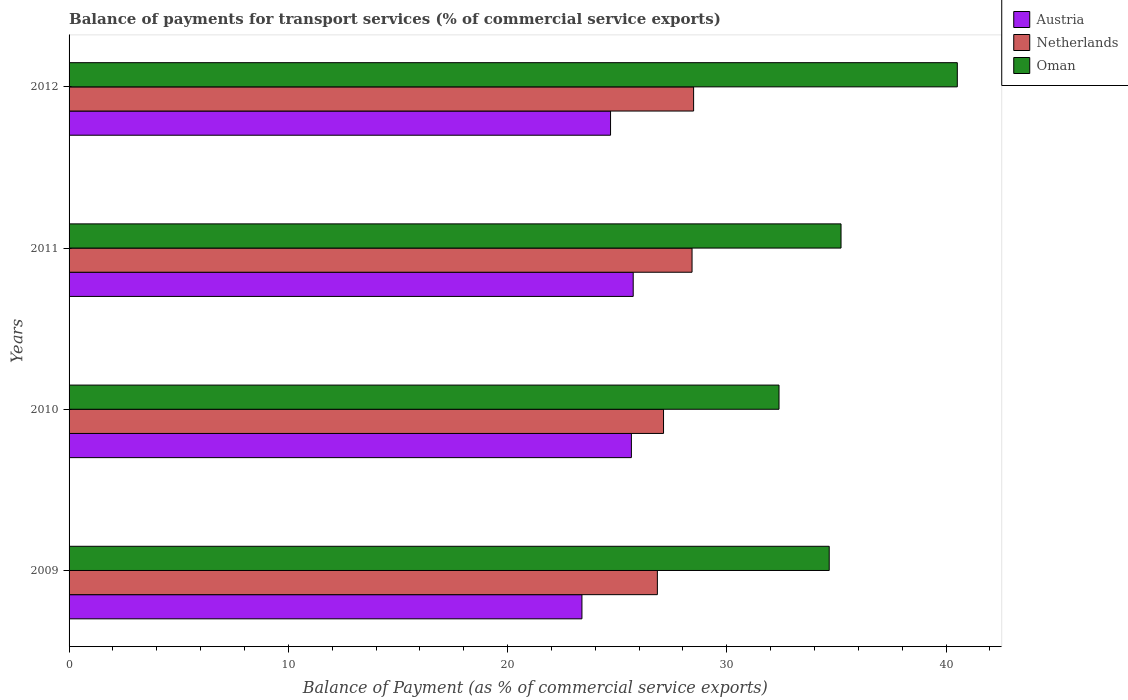How many groups of bars are there?
Offer a very short reply. 4. Are the number of bars on each tick of the Y-axis equal?
Offer a terse response. Yes. How many bars are there on the 4th tick from the top?
Provide a short and direct response. 3. What is the balance of payments for transport services in Oman in 2012?
Your answer should be compact. 40.51. Across all years, what is the maximum balance of payments for transport services in Oman?
Your answer should be very brief. 40.51. Across all years, what is the minimum balance of payments for transport services in Netherlands?
Make the answer very short. 26.83. In which year was the balance of payments for transport services in Oman maximum?
Ensure brevity in your answer.  2012. What is the total balance of payments for transport services in Austria in the graph?
Make the answer very short. 99.47. What is the difference between the balance of payments for transport services in Austria in 2009 and that in 2010?
Your answer should be very brief. -2.26. What is the difference between the balance of payments for transport services in Oman in 2010 and the balance of payments for transport services in Austria in 2009?
Provide a succinct answer. 8.99. What is the average balance of payments for transport services in Austria per year?
Offer a terse response. 24.87. In the year 2010, what is the difference between the balance of payments for transport services in Oman and balance of payments for transport services in Austria?
Your answer should be compact. 6.73. In how many years, is the balance of payments for transport services in Austria greater than 22 %?
Offer a very short reply. 4. What is the ratio of the balance of payments for transport services in Austria in 2011 to that in 2012?
Your answer should be compact. 1.04. What is the difference between the highest and the second highest balance of payments for transport services in Austria?
Give a very brief answer. 0.08. What is the difference between the highest and the lowest balance of payments for transport services in Netherlands?
Offer a very short reply. 1.65. What does the 1st bar from the top in 2010 represents?
Keep it short and to the point. Oman. What does the 3rd bar from the bottom in 2012 represents?
Keep it short and to the point. Oman. How many bars are there?
Your answer should be compact. 12. Are all the bars in the graph horizontal?
Ensure brevity in your answer.  Yes. How many years are there in the graph?
Your response must be concise. 4. Are the values on the major ticks of X-axis written in scientific E-notation?
Ensure brevity in your answer.  No. Does the graph contain grids?
Keep it short and to the point. No. How are the legend labels stacked?
Your response must be concise. Vertical. What is the title of the graph?
Keep it short and to the point. Balance of payments for transport services (% of commercial service exports). Does "Palau" appear as one of the legend labels in the graph?
Offer a terse response. No. What is the label or title of the X-axis?
Provide a short and direct response. Balance of Payment (as % of commercial service exports). What is the Balance of Payment (as % of commercial service exports) in Austria in 2009?
Offer a terse response. 23.39. What is the Balance of Payment (as % of commercial service exports) in Netherlands in 2009?
Provide a short and direct response. 26.83. What is the Balance of Payment (as % of commercial service exports) of Oman in 2009?
Provide a short and direct response. 34.67. What is the Balance of Payment (as % of commercial service exports) in Austria in 2010?
Make the answer very short. 25.65. What is the Balance of Payment (as % of commercial service exports) in Netherlands in 2010?
Provide a short and direct response. 27.11. What is the Balance of Payment (as % of commercial service exports) of Oman in 2010?
Provide a succinct answer. 32.38. What is the Balance of Payment (as % of commercial service exports) of Austria in 2011?
Provide a short and direct response. 25.73. What is the Balance of Payment (as % of commercial service exports) of Netherlands in 2011?
Your answer should be compact. 28.41. What is the Balance of Payment (as % of commercial service exports) of Oman in 2011?
Provide a short and direct response. 35.21. What is the Balance of Payment (as % of commercial service exports) of Austria in 2012?
Your answer should be very brief. 24.7. What is the Balance of Payment (as % of commercial service exports) in Netherlands in 2012?
Give a very brief answer. 28.49. What is the Balance of Payment (as % of commercial service exports) of Oman in 2012?
Offer a very short reply. 40.51. Across all years, what is the maximum Balance of Payment (as % of commercial service exports) of Austria?
Your answer should be very brief. 25.73. Across all years, what is the maximum Balance of Payment (as % of commercial service exports) of Netherlands?
Make the answer very short. 28.49. Across all years, what is the maximum Balance of Payment (as % of commercial service exports) of Oman?
Keep it short and to the point. 40.51. Across all years, what is the minimum Balance of Payment (as % of commercial service exports) in Austria?
Your answer should be compact. 23.39. Across all years, what is the minimum Balance of Payment (as % of commercial service exports) of Netherlands?
Your answer should be compact. 26.83. Across all years, what is the minimum Balance of Payment (as % of commercial service exports) of Oman?
Provide a succinct answer. 32.38. What is the total Balance of Payment (as % of commercial service exports) in Austria in the graph?
Keep it short and to the point. 99.47. What is the total Balance of Payment (as % of commercial service exports) in Netherlands in the graph?
Offer a terse response. 110.85. What is the total Balance of Payment (as % of commercial service exports) of Oman in the graph?
Ensure brevity in your answer.  142.78. What is the difference between the Balance of Payment (as % of commercial service exports) in Austria in 2009 and that in 2010?
Offer a terse response. -2.26. What is the difference between the Balance of Payment (as % of commercial service exports) in Netherlands in 2009 and that in 2010?
Make the answer very short. -0.28. What is the difference between the Balance of Payment (as % of commercial service exports) in Oman in 2009 and that in 2010?
Provide a succinct answer. 2.29. What is the difference between the Balance of Payment (as % of commercial service exports) of Austria in 2009 and that in 2011?
Provide a short and direct response. -2.34. What is the difference between the Balance of Payment (as % of commercial service exports) of Netherlands in 2009 and that in 2011?
Ensure brevity in your answer.  -1.58. What is the difference between the Balance of Payment (as % of commercial service exports) in Oman in 2009 and that in 2011?
Make the answer very short. -0.54. What is the difference between the Balance of Payment (as % of commercial service exports) of Austria in 2009 and that in 2012?
Offer a terse response. -1.31. What is the difference between the Balance of Payment (as % of commercial service exports) in Netherlands in 2009 and that in 2012?
Keep it short and to the point. -1.65. What is the difference between the Balance of Payment (as % of commercial service exports) of Oman in 2009 and that in 2012?
Your answer should be very brief. -5.84. What is the difference between the Balance of Payment (as % of commercial service exports) of Austria in 2010 and that in 2011?
Provide a short and direct response. -0.08. What is the difference between the Balance of Payment (as % of commercial service exports) of Netherlands in 2010 and that in 2011?
Provide a succinct answer. -1.3. What is the difference between the Balance of Payment (as % of commercial service exports) of Oman in 2010 and that in 2011?
Your answer should be compact. -2.83. What is the difference between the Balance of Payment (as % of commercial service exports) of Austria in 2010 and that in 2012?
Make the answer very short. 0.95. What is the difference between the Balance of Payment (as % of commercial service exports) in Netherlands in 2010 and that in 2012?
Your answer should be compact. -1.37. What is the difference between the Balance of Payment (as % of commercial service exports) in Oman in 2010 and that in 2012?
Your answer should be compact. -8.13. What is the difference between the Balance of Payment (as % of commercial service exports) of Austria in 2011 and that in 2012?
Your answer should be very brief. 1.03. What is the difference between the Balance of Payment (as % of commercial service exports) of Netherlands in 2011 and that in 2012?
Provide a short and direct response. -0.07. What is the difference between the Balance of Payment (as % of commercial service exports) of Oman in 2011 and that in 2012?
Ensure brevity in your answer.  -5.3. What is the difference between the Balance of Payment (as % of commercial service exports) in Austria in 2009 and the Balance of Payment (as % of commercial service exports) in Netherlands in 2010?
Provide a short and direct response. -3.72. What is the difference between the Balance of Payment (as % of commercial service exports) of Austria in 2009 and the Balance of Payment (as % of commercial service exports) of Oman in 2010?
Your answer should be very brief. -8.99. What is the difference between the Balance of Payment (as % of commercial service exports) of Netherlands in 2009 and the Balance of Payment (as % of commercial service exports) of Oman in 2010?
Keep it short and to the point. -5.55. What is the difference between the Balance of Payment (as % of commercial service exports) in Austria in 2009 and the Balance of Payment (as % of commercial service exports) in Netherlands in 2011?
Your answer should be compact. -5.02. What is the difference between the Balance of Payment (as % of commercial service exports) of Austria in 2009 and the Balance of Payment (as % of commercial service exports) of Oman in 2011?
Keep it short and to the point. -11.82. What is the difference between the Balance of Payment (as % of commercial service exports) in Netherlands in 2009 and the Balance of Payment (as % of commercial service exports) in Oman in 2011?
Provide a short and direct response. -8.38. What is the difference between the Balance of Payment (as % of commercial service exports) in Austria in 2009 and the Balance of Payment (as % of commercial service exports) in Netherlands in 2012?
Provide a succinct answer. -5.09. What is the difference between the Balance of Payment (as % of commercial service exports) of Austria in 2009 and the Balance of Payment (as % of commercial service exports) of Oman in 2012?
Ensure brevity in your answer.  -17.12. What is the difference between the Balance of Payment (as % of commercial service exports) in Netherlands in 2009 and the Balance of Payment (as % of commercial service exports) in Oman in 2012?
Provide a short and direct response. -13.68. What is the difference between the Balance of Payment (as % of commercial service exports) in Austria in 2010 and the Balance of Payment (as % of commercial service exports) in Netherlands in 2011?
Your answer should be very brief. -2.77. What is the difference between the Balance of Payment (as % of commercial service exports) of Austria in 2010 and the Balance of Payment (as % of commercial service exports) of Oman in 2011?
Make the answer very short. -9.56. What is the difference between the Balance of Payment (as % of commercial service exports) of Netherlands in 2010 and the Balance of Payment (as % of commercial service exports) of Oman in 2011?
Ensure brevity in your answer.  -8.1. What is the difference between the Balance of Payment (as % of commercial service exports) of Austria in 2010 and the Balance of Payment (as % of commercial service exports) of Netherlands in 2012?
Offer a terse response. -2.84. What is the difference between the Balance of Payment (as % of commercial service exports) of Austria in 2010 and the Balance of Payment (as % of commercial service exports) of Oman in 2012?
Your response must be concise. -14.87. What is the difference between the Balance of Payment (as % of commercial service exports) in Netherlands in 2010 and the Balance of Payment (as % of commercial service exports) in Oman in 2012?
Your answer should be compact. -13.4. What is the difference between the Balance of Payment (as % of commercial service exports) of Austria in 2011 and the Balance of Payment (as % of commercial service exports) of Netherlands in 2012?
Give a very brief answer. -2.76. What is the difference between the Balance of Payment (as % of commercial service exports) in Austria in 2011 and the Balance of Payment (as % of commercial service exports) in Oman in 2012?
Your response must be concise. -14.78. What is the difference between the Balance of Payment (as % of commercial service exports) of Netherlands in 2011 and the Balance of Payment (as % of commercial service exports) of Oman in 2012?
Give a very brief answer. -12.1. What is the average Balance of Payment (as % of commercial service exports) of Austria per year?
Provide a succinct answer. 24.87. What is the average Balance of Payment (as % of commercial service exports) in Netherlands per year?
Give a very brief answer. 27.71. What is the average Balance of Payment (as % of commercial service exports) in Oman per year?
Your answer should be compact. 35.69. In the year 2009, what is the difference between the Balance of Payment (as % of commercial service exports) of Austria and Balance of Payment (as % of commercial service exports) of Netherlands?
Keep it short and to the point. -3.44. In the year 2009, what is the difference between the Balance of Payment (as % of commercial service exports) in Austria and Balance of Payment (as % of commercial service exports) in Oman?
Offer a very short reply. -11.28. In the year 2009, what is the difference between the Balance of Payment (as % of commercial service exports) of Netherlands and Balance of Payment (as % of commercial service exports) of Oman?
Your answer should be very brief. -7.84. In the year 2010, what is the difference between the Balance of Payment (as % of commercial service exports) of Austria and Balance of Payment (as % of commercial service exports) of Netherlands?
Make the answer very short. -1.47. In the year 2010, what is the difference between the Balance of Payment (as % of commercial service exports) of Austria and Balance of Payment (as % of commercial service exports) of Oman?
Ensure brevity in your answer.  -6.73. In the year 2010, what is the difference between the Balance of Payment (as % of commercial service exports) of Netherlands and Balance of Payment (as % of commercial service exports) of Oman?
Provide a succinct answer. -5.27. In the year 2011, what is the difference between the Balance of Payment (as % of commercial service exports) in Austria and Balance of Payment (as % of commercial service exports) in Netherlands?
Provide a succinct answer. -2.68. In the year 2011, what is the difference between the Balance of Payment (as % of commercial service exports) of Austria and Balance of Payment (as % of commercial service exports) of Oman?
Give a very brief answer. -9.48. In the year 2011, what is the difference between the Balance of Payment (as % of commercial service exports) of Netherlands and Balance of Payment (as % of commercial service exports) of Oman?
Your answer should be very brief. -6.8. In the year 2012, what is the difference between the Balance of Payment (as % of commercial service exports) of Austria and Balance of Payment (as % of commercial service exports) of Netherlands?
Provide a succinct answer. -3.79. In the year 2012, what is the difference between the Balance of Payment (as % of commercial service exports) of Austria and Balance of Payment (as % of commercial service exports) of Oman?
Your response must be concise. -15.82. In the year 2012, what is the difference between the Balance of Payment (as % of commercial service exports) in Netherlands and Balance of Payment (as % of commercial service exports) in Oman?
Ensure brevity in your answer.  -12.03. What is the ratio of the Balance of Payment (as % of commercial service exports) in Austria in 2009 to that in 2010?
Provide a succinct answer. 0.91. What is the ratio of the Balance of Payment (as % of commercial service exports) in Oman in 2009 to that in 2010?
Offer a very short reply. 1.07. What is the ratio of the Balance of Payment (as % of commercial service exports) of Austria in 2009 to that in 2011?
Provide a succinct answer. 0.91. What is the ratio of the Balance of Payment (as % of commercial service exports) in Netherlands in 2009 to that in 2011?
Provide a succinct answer. 0.94. What is the ratio of the Balance of Payment (as % of commercial service exports) of Oman in 2009 to that in 2011?
Ensure brevity in your answer.  0.98. What is the ratio of the Balance of Payment (as % of commercial service exports) of Austria in 2009 to that in 2012?
Offer a terse response. 0.95. What is the ratio of the Balance of Payment (as % of commercial service exports) in Netherlands in 2009 to that in 2012?
Keep it short and to the point. 0.94. What is the ratio of the Balance of Payment (as % of commercial service exports) in Oman in 2009 to that in 2012?
Ensure brevity in your answer.  0.86. What is the ratio of the Balance of Payment (as % of commercial service exports) of Netherlands in 2010 to that in 2011?
Ensure brevity in your answer.  0.95. What is the ratio of the Balance of Payment (as % of commercial service exports) of Oman in 2010 to that in 2011?
Make the answer very short. 0.92. What is the ratio of the Balance of Payment (as % of commercial service exports) of Austria in 2010 to that in 2012?
Provide a succinct answer. 1.04. What is the ratio of the Balance of Payment (as % of commercial service exports) of Netherlands in 2010 to that in 2012?
Offer a very short reply. 0.95. What is the ratio of the Balance of Payment (as % of commercial service exports) in Oman in 2010 to that in 2012?
Provide a succinct answer. 0.8. What is the ratio of the Balance of Payment (as % of commercial service exports) in Austria in 2011 to that in 2012?
Make the answer very short. 1.04. What is the ratio of the Balance of Payment (as % of commercial service exports) of Oman in 2011 to that in 2012?
Give a very brief answer. 0.87. What is the difference between the highest and the second highest Balance of Payment (as % of commercial service exports) of Austria?
Offer a terse response. 0.08. What is the difference between the highest and the second highest Balance of Payment (as % of commercial service exports) of Netherlands?
Your answer should be compact. 0.07. What is the difference between the highest and the second highest Balance of Payment (as % of commercial service exports) of Oman?
Provide a short and direct response. 5.3. What is the difference between the highest and the lowest Balance of Payment (as % of commercial service exports) in Austria?
Provide a short and direct response. 2.34. What is the difference between the highest and the lowest Balance of Payment (as % of commercial service exports) in Netherlands?
Ensure brevity in your answer.  1.65. What is the difference between the highest and the lowest Balance of Payment (as % of commercial service exports) of Oman?
Give a very brief answer. 8.13. 